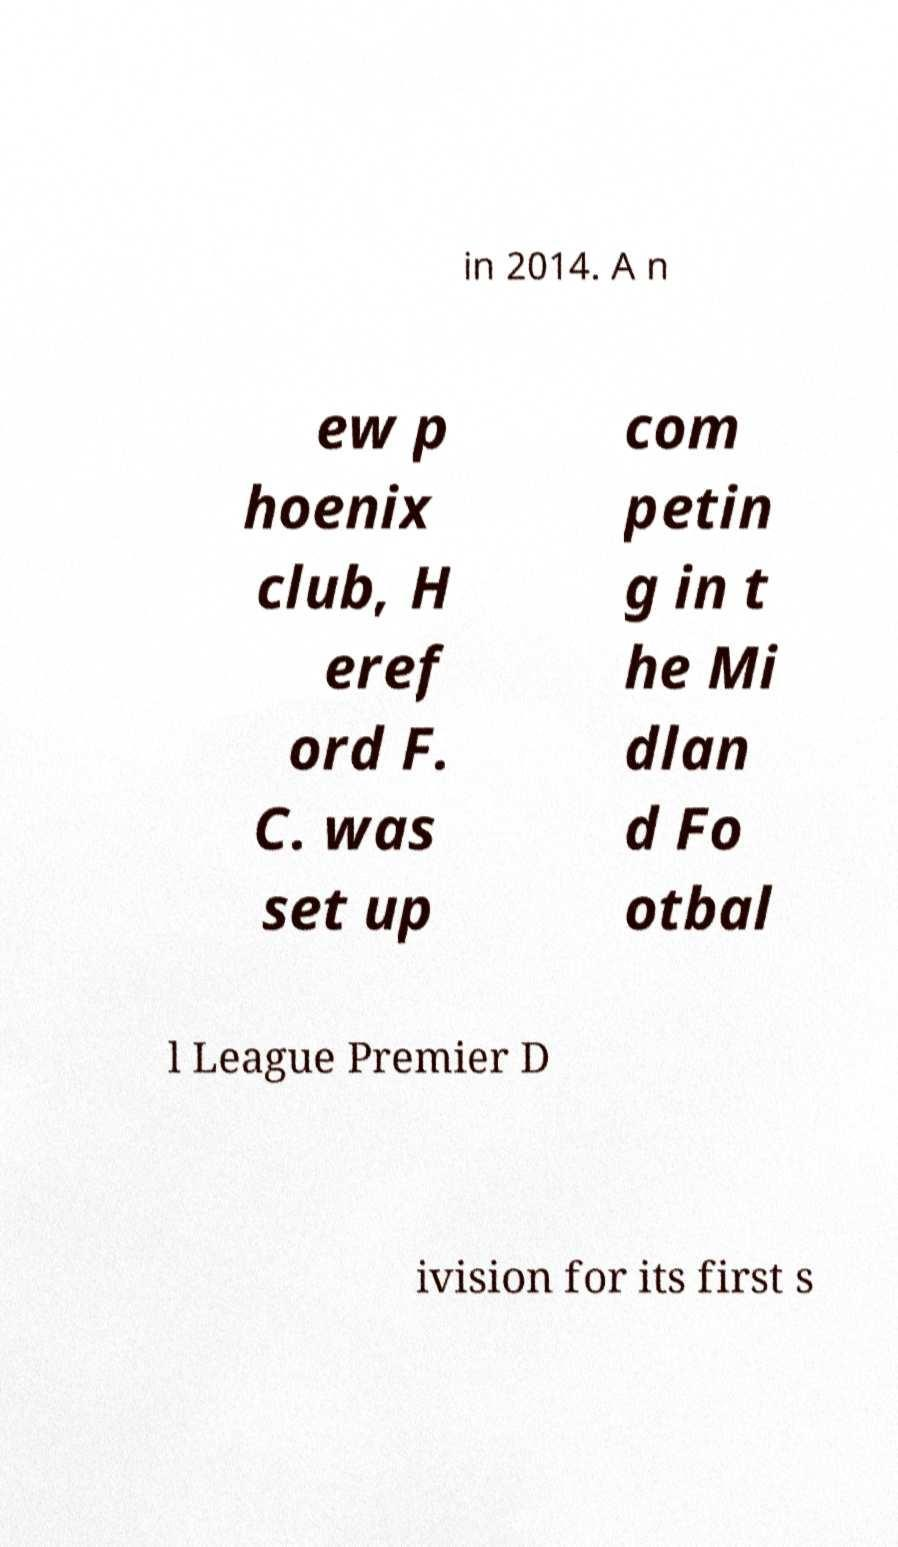There's text embedded in this image that I need extracted. Can you transcribe it verbatim? in 2014. A n ew p hoenix club, H eref ord F. C. was set up com petin g in t he Mi dlan d Fo otbal l League Premier D ivision for its first s 